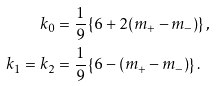Convert formula to latex. <formula><loc_0><loc_0><loc_500><loc_500>k _ { 0 } & = \frac { 1 } { 9 } \left \{ 6 + 2 ( m _ { + } - m _ { - } ) \right \} , \\ k _ { 1 } = k _ { 2 } & = \frac { 1 } { 9 } \left \{ 6 - ( m _ { + } - m _ { - } ) \right \} .</formula> 